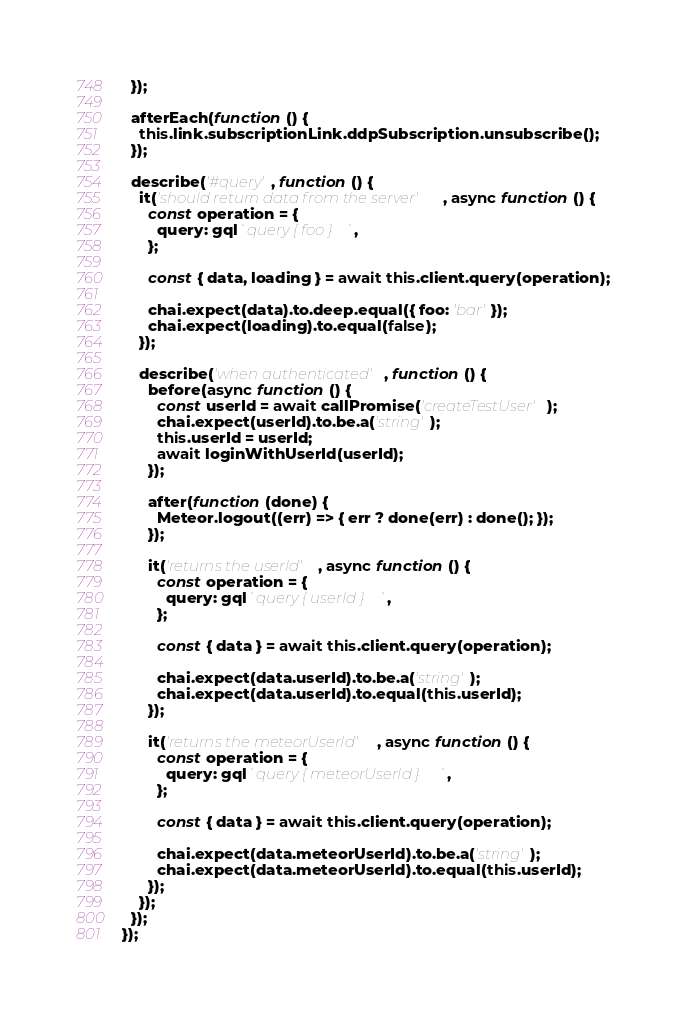Convert code to text. <code><loc_0><loc_0><loc_500><loc_500><_JavaScript_>  });

  afterEach(function () {
    this.link.subscriptionLink.ddpSubscription.unsubscribe();
  });

  describe('#query', function () {
    it('should return data from the server', async function () {
      const operation = {
        query: gql`query { foo }`,
      };

      const { data, loading } = await this.client.query(operation);

      chai.expect(data).to.deep.equal({ foo: 'bar' });
      chai.expect(loading).to.equal(false);
    });

    describe('when authenticated', function () {
      before(async function () {
        const userId = await callPromise('createTestUser');
        chai.expect(userId).to.be.a('string');
        this.userId = userId;
        await loginWithUserId(userId);
      });

      after(function (done) {
        Meteor.logout((err) => { err ? done(err) : done(); });
      });

      it('returns the userId', async function () {
        const operation = {
          query: gql`query { userId }`,
        };

        const { data } = await this.client.query(operation);

        chai.expect(data.userId).to.be.a('string');
        chai.expect(data.userId).to.equal(this.userId);
      });

      it('returns the meteorUserId', async function () {
        const operation = {
          query: gql`query { meteorUserId }`,
        };

        const { data } = await this.client.query(operation);

        chai.expect(data.meteorUserId).to.be.a('string');
        chai.expect(data.meteorUserId).to.equal(this.userId);
      });
    });
  });
});

</code> 